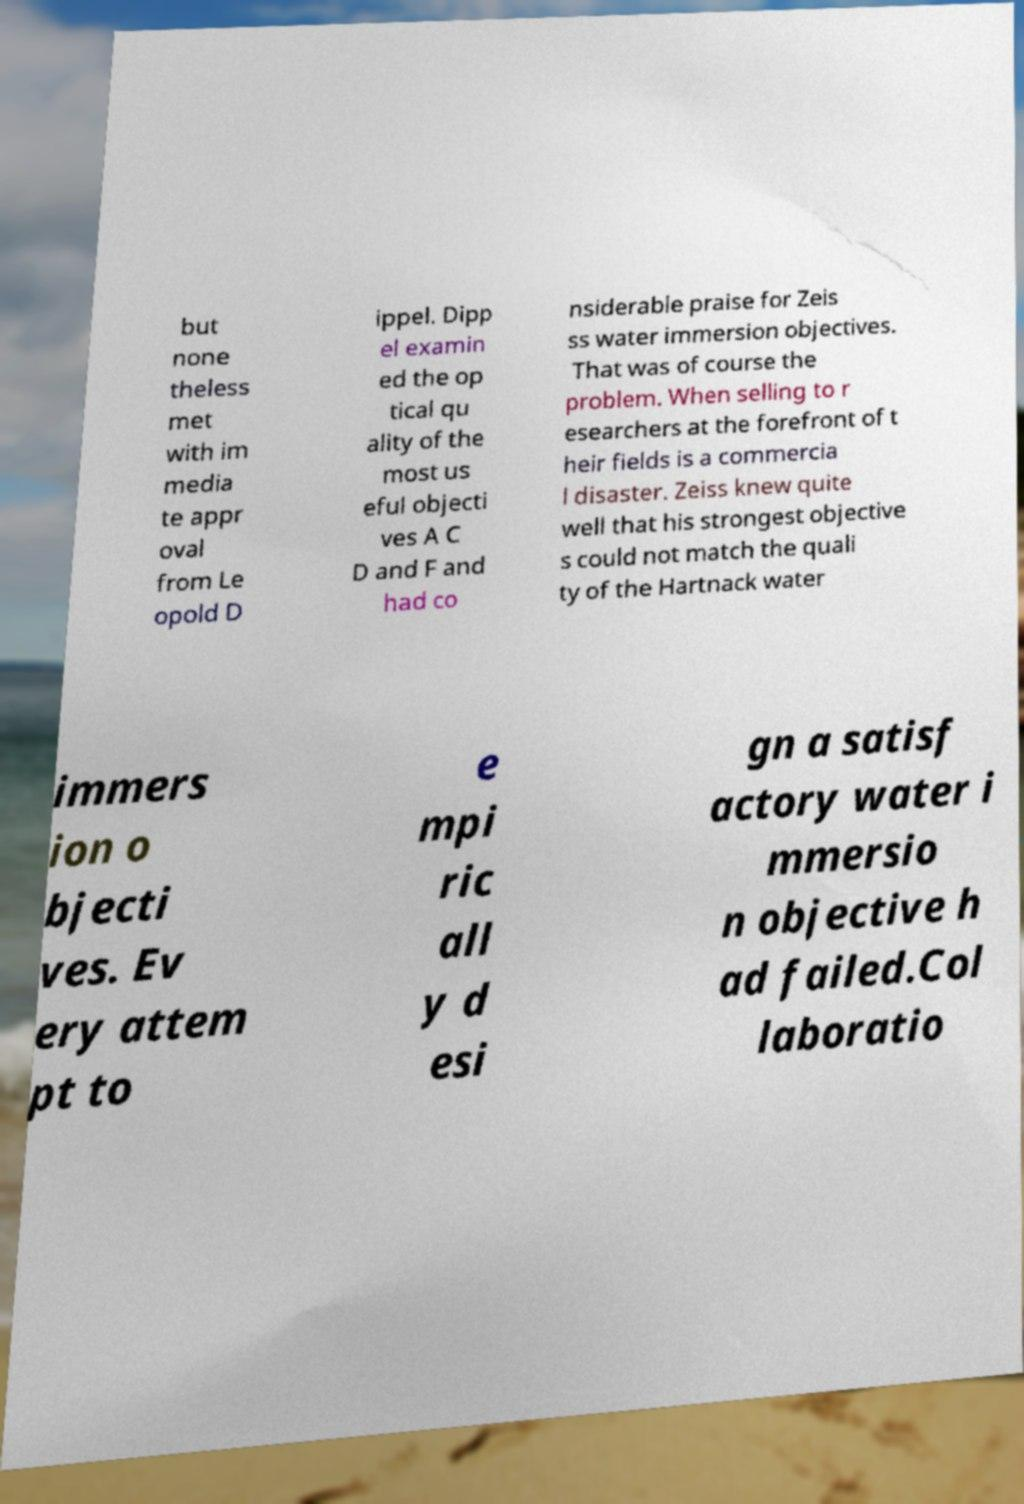Please identify and transcribe the text found in this image. but none theless met with im media te appr oval from Le opold D ippel. Dipp el examin ed the op tical qu ality of the most us eful objecti ves A C D and F and had co nsiderable praise for Zeis ss water immersion objectives. That was of course the problem. When selling to r esearchers at the forefront of t heir fields is a commercia l disaster. Zeiss knew quite well that his strongest objective s could not match the quali ty of the Hartnack water immers ion o bjecti ves. Ev ery attem pt to e mpi ric all y d esi gn a satisf actory water i mmersio n objective h ad failed.Col laboratio 